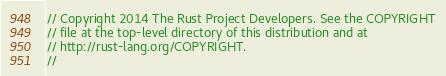<code> <loc_0><loc_0><loc_500><loc_500><_Rust_>// Copyright 2014 The Rust Project Developers. See the COPYRIGHT
// file at the top-level directory of this distribution and at
// http://rust-lang.org/COPYRIGHT.
//</code> 